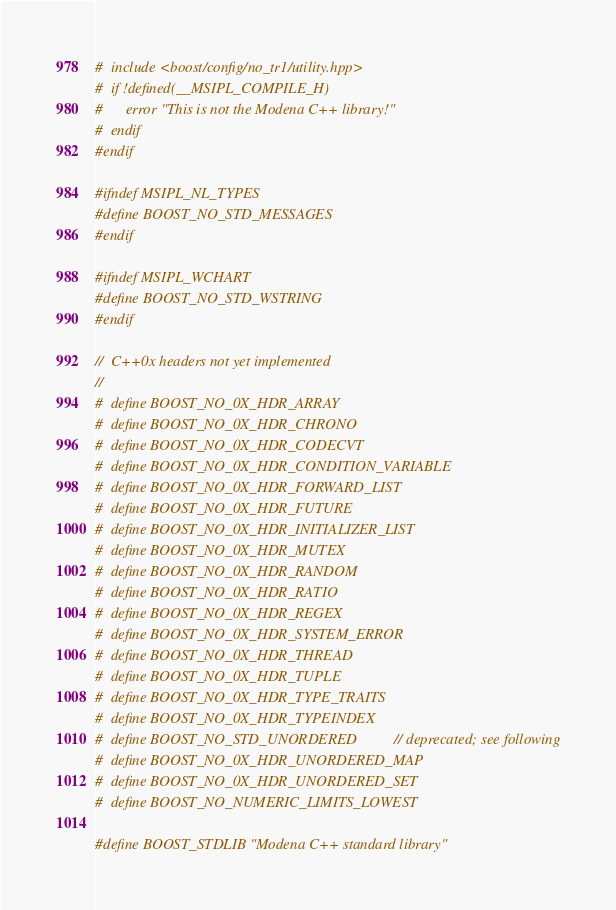Convert code to text. <code><loc_0><loc_0><loc_500><loc_500><_C++_>#  include <boost/config/no_tr1/utility.hpp>
#  if !defined(__MSIPL_COMPILE_H)
#      error "This is not the Modena C++ library!"
#  endif
#endif

#ifndef MSIPL_NL_TYPES
#define BOOST_NO_STD_MESSAGES
#endif

#ifndef MSIPL_WCHART
#define BOOST_NO_STD_WSTRING
#endif

//  C++0x headers not yet implemented
//
#  define BOOST_NO_0X_HDR_ARRAY
#  define BOOST_NO_0X_HDR_CHRONO
#  define BOOST_NO_0X_HDR_CODECVT
#  define BOOST_NO_0X_HDR_CONDITION_VARIABLE
#  define BOOST_NO_0X_HDR_FORWARD_LIST
#  define BOOST_NO_0X_HDR_FUTURE
#  define BOOST_NO_0X_HDR_INITIALIZER_LIST
#  define BOOST_NO_0X_HDR_MUTEX
#  define BOOST_NO_0X_HDR_RANDOM
#  define BOOST_NO_0X_HDR_RATIO
#  define BOOST_NO_0X_HDR_REGEX
#  define BOOST_NO_0X_HDR_SYSTEM_ERROR
#  define BOOST_NO_0X_HDR_THREAD
#  define BOOST_NO_0X_HDR_TUPLE
#  define BOOST_NO_0X_HDR_TYPE_TRAITS
#  define BOOST_NO_0X_HDR_TYPEINDEX
#  define BOOST_NO_STD_UNORDERED        // deprecated; see following
#  define BOOST_NO_0X_HDR_UNORDERED_MAP
#  define BOOST_NO_0X_HDR_UNORDERED_SET
#  define BOOST_NO_NUMERIC_LIMITS_LOWEST

#define BOOST_STDLIB "Modena C++ standard library"





</code> 